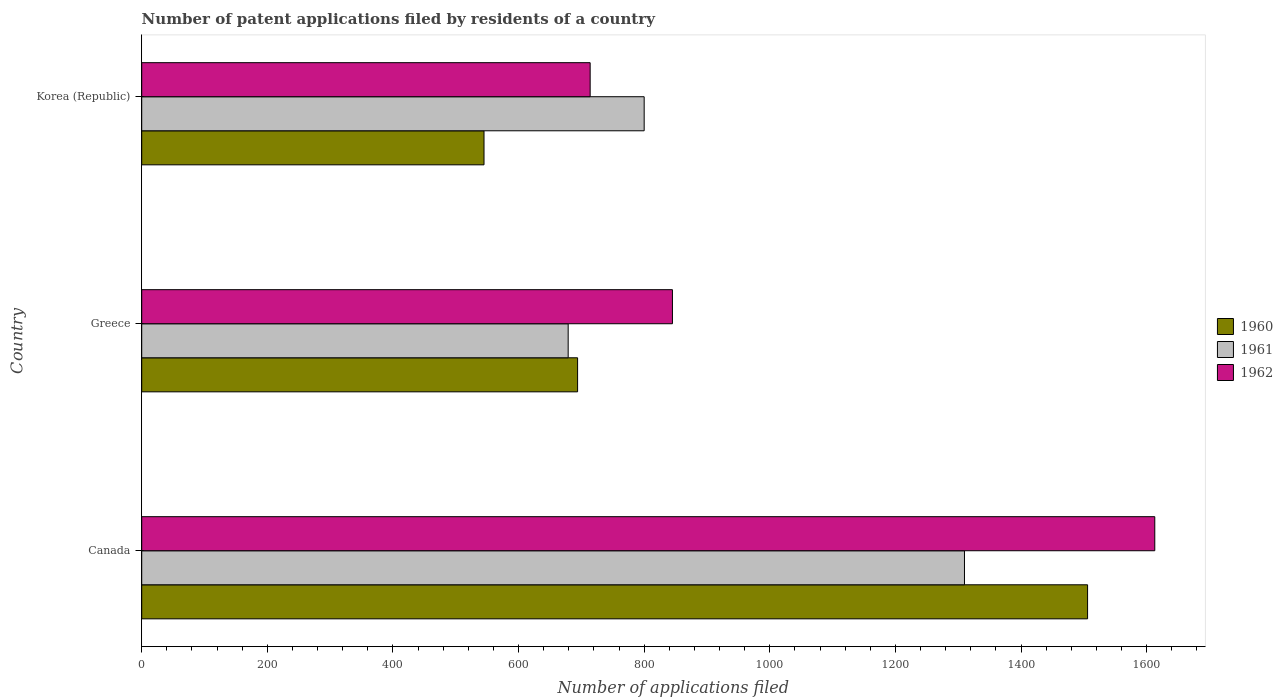How many groups of bars are there?
Your answer should be very brief. 3. How many bars are there on the 1st tick from the top?
Provide a succinct answer. 3. What is the label of the 1st group of bars from the top?
Your answer should be very brief. Korea (Republic). What is the number of applications filed in 1961 in Canada?
Your answer should be very brief. 1310. Across all countries, what is the maximum number of applications filed in 1962?
Make the answer very short. 1613. Across all countries, what is the minimum number of applications filed in 1962?
Provide a short and direct response. 714. In which country was the number of applications filed in 1961 maximum?
Ensure brevity in your answer.  Canada. In which country was the number of applications filed in 1961 minimum?
Make the answer very short. Greece. What is the total number of applications filed in 1960 in the graph?
Your answer should be very brief. 2745. What is the difference between the number of applications filed in 1960 in Canada and that in Greece?
Make the answer very short. 812. What is the difference between the number of applications filed in 1960 in Canada and the number of applications filed in 1961 in Korea (Republic)?
Ensure brevity in your answer.  706. What is the average number of applications filed in 1960 per country?
Give a very brief answer. 915. In how many countries, is the number of applications filed in 1961 greater than 640 ?
Offer a terse response. 3. What is the ratio of the number of applications filed in 1960 in Greece to that in Korea (Republic)?
Your answer should be compact. 1.27. Is the number of applications filed in 1961 in Canada less than that in Korea (Republic)?
Your answer should be very brief. No. What is the difference between the highest and the second highest number of applications filed in 1962?
Offer a very short reply. 768. What is the difference between the highest and the lowest number of applications filed in 1960?
Ensure brevity in your answer.  961. Is it the case that in every country, the sum of the number of applications filed in 1961 and number of applications filed in 1962 is greater than the number of applications filed in 1960?
Your response must be concise. Yes. How many countries are there in the graph?
Your answer should be compact. 3. What is the difference between two consecutive major ticks on the X-axis?
Offer a very short reply. 200. Does the graph contain grids?
Your answer should be very brief. No. How many legend labels are there?
Keep it short and to the point. 3. What is the title of the graph?
Offer a very short reply. Number of patent applications filed by residents of a country. Does "2004" appear as one of the legend labels in the graph?
Your answer should be very brief. No. What is the label or title of the X-axis?
Offer a very short reply. Number of applications filed. What is the Number of applications filed of 1960 in Canada?
Offer a terse response. 1506. What is the Number of applications filed in 1961 in Canada?
Give a very brief answer. 1310. What is the Number of applications filed in 1962 in Canada?
Keep it short and to the point. 1613. What is the Number of applications filed of 1960 in Greece?
Give a very brief answer. 694. What is the Number of applications filed of 1961 in Greece?
Your answer should be very brief. 679. What is the Number of applications filed of 1962 in Greece?
Offer a terse response. 845. What is the Number of applications filed of 1960 in Korea (Republic)?
Keep it short and to the point. 545. What is the Number of applications filed in 1961 in Korea (Republic)?
Make the answer very short. 800. What is the Number of applications filed of 1962 in Korea (Republic)?
Keep it short and to the point. 714. Across all countries, what is the maximum Number of applications filed in 1960?
Keep it short and to the point. 1506. Across all countries, what is the maximum Number of applications filed in 1961?
Give a very brief answer. 1310. Across all countries, what is the maximum Number of applications filed in 1962?
Keep it short and to the point. 1613. Across all countries, what is the minimum Number of applications filed of 1960?
Offer a terse response. 545. Across all countries, what is the minimum Number of applications filed in 1961?
Offer a terse response. 679. Across all countries, what is the minimum Number of applications filed in 1962?
Offer a very short reply. 714. What is the total Number of applications filed of 1960 in the graph?
Offer a very short reply. 2745. What is the total Number of applications filed in 1961 in the graph?
Provide a succinct answer. 2789. What is the total Number of applications filed of 1962 in the graph?
Your answer should be compact. 3172. What is the difference between the Number of applications filed in 1960 in Canada and that in Greece?
Make the answer very short. 812. What is the difference between the Number of applications filed in 1961 in Canada and that in Greece?
Keep it short and to the point. 631. What is the difference between the Number of applications filed in 1962 in Canada and that in Greece?
Ensure brevity in your answer.  768. What is the difference between the Number of applications filed in 1960 in Canada and that in Korea (Republic)?
Ensure brevity in your answer.  961. What is the difference between the Number of applications filed of 1961 in Canada and that in Korea (Republic)?
Your response must be concise. 510. What is the difference between the Number of applications filed in 1962 in Canada and that in Korea (Republic)?
Offer a terse response. 899. What is the difference between the Number of applications filed in 1960 in Greece and that in Korea (Republic)?
Your answer should be very brief. 149. What is the difference between the Number of applications filed of 1961 in Greece and that in Korea (Republic)?
Ensure brevity in your answer.  -121. What is the difference between the Number of applications filed of 1962 in Greece and that in Korea (Republic)?
Your response must be concise. 131. What is the difference between the Number of applications filed in 1960 in Canada and the Number of applications filed in 1961 in Greece?
Offer a very short reply. 827. What is the difference between the Number of applications filed of 1960 in Canada and the Number of applications filed of 1962 in Greece?
Ensure brevity in your answer.  661. What is the difference between the Number of applications filed of 1961 in Canada and the Number of applications filed of 1962 in Greece?
Provide a succinct answer. 465. What is the difference between the Number of applications filed in 1960 in Canada and the Number of applications filed in 1961 in Korea (Republic)?
Make the answer very short. 706. What is the difference between the Number of applications filed of 1960 in Canada and the Number of applications filed of 1962 in Korea (Republic)?
Make the answer very short. 792. What is the difference between the Number of applications filed of 1961 in Canada and the Number of applications filed of 1962 in Korea (Republic)?
Your response must be concise. 596. What is the difference between the Number of applications filed in 1960 in Greece and the Number of applications filed in 1961 in Korea (Republic)?
Provide a short and direct response. -106. What is the difference between the Number of applications filed of 1960 in Greece and the Number of applications filed of 1962 in Korea (Republic)?
Make the answer very short. -20. What is the difference between the Number of applications filed in 1961 in Greece and the Number of applications filed in 1962 in Korea (Republic)?
Offer a terse response. -35. What is the average Number of applications filed of 1960 per country?
Offer a terse response. 915. What is the average Number of applications filed of 1961 per country?
Provide a succinct answer. 929.67. What is the average Number of applications filed of 1962 per country?
Provide a short and direct response. 1057.33. What is the difference between the Number of applications filed of 1960 and Number of applications filed of 1961 in Canada?
Your answer should be compact. 196. What is the difference between the Number of applications filed in 1960 and Number of applications filed in 1962 in Canada?
Offer a very short reply. -107. What is the difference between the Number of applications filed in 1961 and Number of applications filed in 1962 in Canada?
Provide a succinct answer. -303. What is the difference between the Number of applications filed of 1960 and Number of applications filed of 1962 in Greece?
Keep it short and to the point. -151. What is the difference between the Number of applications filed of 1961 and Number of applications filed of 1962 in Greece?
Your response must be concise. -166. What is the difference between the Number of applications filed in 1960 and Number of applications filed in 1961 in Korea (Republic)?
Offer a very short reply. -255. What is the difference between the Number of applications filed of 1960 and Number of applications filed of 1962 in Korea (Republic)?
Your response must be concise. -169. What is the difference between the Number of applications filed in 1961 and Number of applications filed in 1962 in Korea (Republic)?
Your response must be concise. 86. What is the ratio of the Number of applications filed in 1960 in Canada to that in Greece?
Offer a terse response. 2.17. What is the ratio of the Number of applications filed of 1961 in Canada to that in Greece?
Keep it short and to the point. 1.93. What is the ratio of the Number of applications filed in 1962 in Canada to that in Greece?
Make the answer very short. 1.91. What is the ratio of the Number of applications filed of 1960 in Canada to that in Korea (Republic)?
Provide a succinct answer. 2.76. What is the ratio of the Number of applications filed in 1961 in Canada to that in Korea (Republic)?
Provide a short and direct response. 1.64. What is the ratio of the Number of applications filed of 1962 in Canada to that in Korea (Republic)?
Give a very brief answer. 2.26. What is the ratio of the Number of applications filed of 1960 in Greece to that in Korea (Republic)?
Offer a terse response. 1.27. What is the ratio of the Number of applications filed of 1961 in Greece to that in Korea (Republic)?
Offer a very short reply. 0.85. What is the ratio of the Number of applications filed in 1962 in Greece to that in Korea (Republic)?
Give a very brief answer. 1.18. What is the difference between the highest and the second highest Number of applications filed of 1960?
Provide a short and direct response. 812. What is the difference between the highest and the second highest Number of applications filed of 1961?
Offer a very short reply. 510. What is the difference between the highest and the second highest Number of applications filed in 1962?
Your response must be concise. 768. What is the difference between the highest and the lowest Number of applications filed of 1960?
Make the answer very short. 961. What is the difference between the highest and the lowest Number of applications filed in 1961?
Make the answer very short. 631. What is the difference between the highest and the lowest Number of applications filed in 1962?
Provide a succinct answer. 899. 